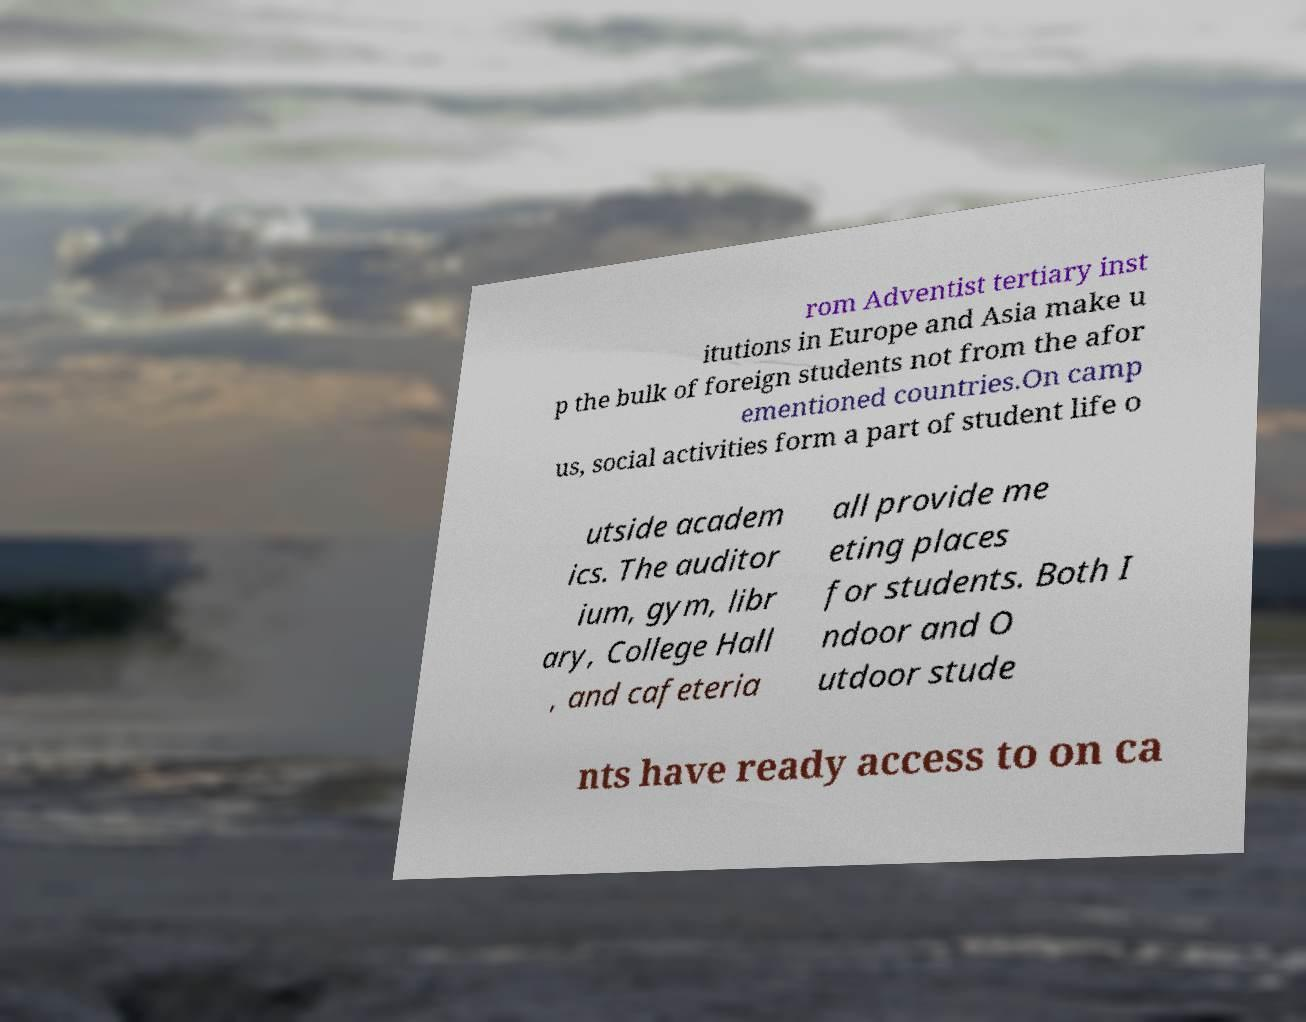Can you accurately transcribe the text from the provided image for me? rom Adventist tertiary inst itutions in Europe and Asia make u p the bulk of foreign students not from the afor ementioned countries.On camp us, social activities form a part of student life o utside academ ics. The auditor ium, gym, libr ary, College Hall , and cafeteria all provide me eting places for students. Both I ndoor and O utdoor stude nts have ready access to on ca 